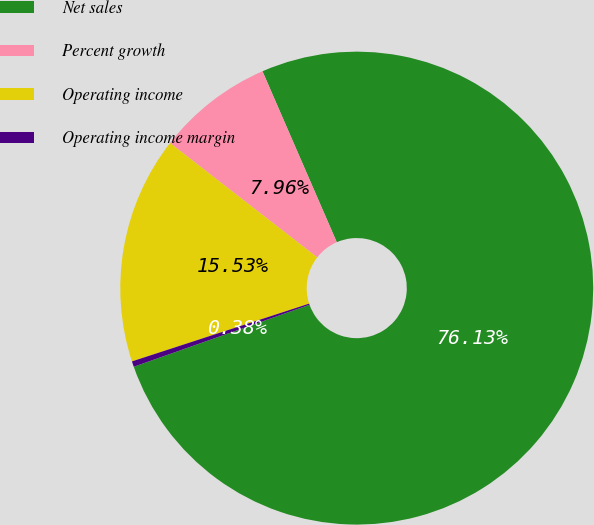<chart> <loc_0><loc_0><loc_500><loc_500><pie_chart><fcel>Net sales<fcel>Percent growth<fcel>Operating income<fcel>Operating income margin<nl><fcel>76.13%<fcel>7.96%<fcel>15.53%<fcel>0.38%<nl></chart> 